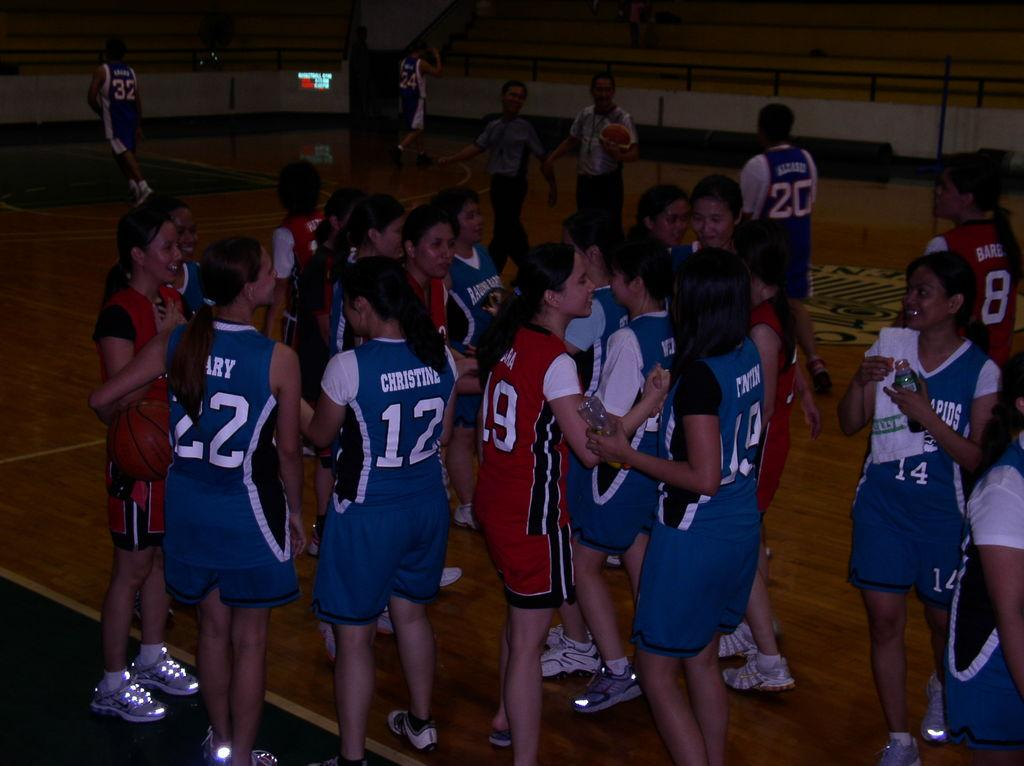<image>
Render a clear and concise summary of the photo. a few players with one wearing the number 12 